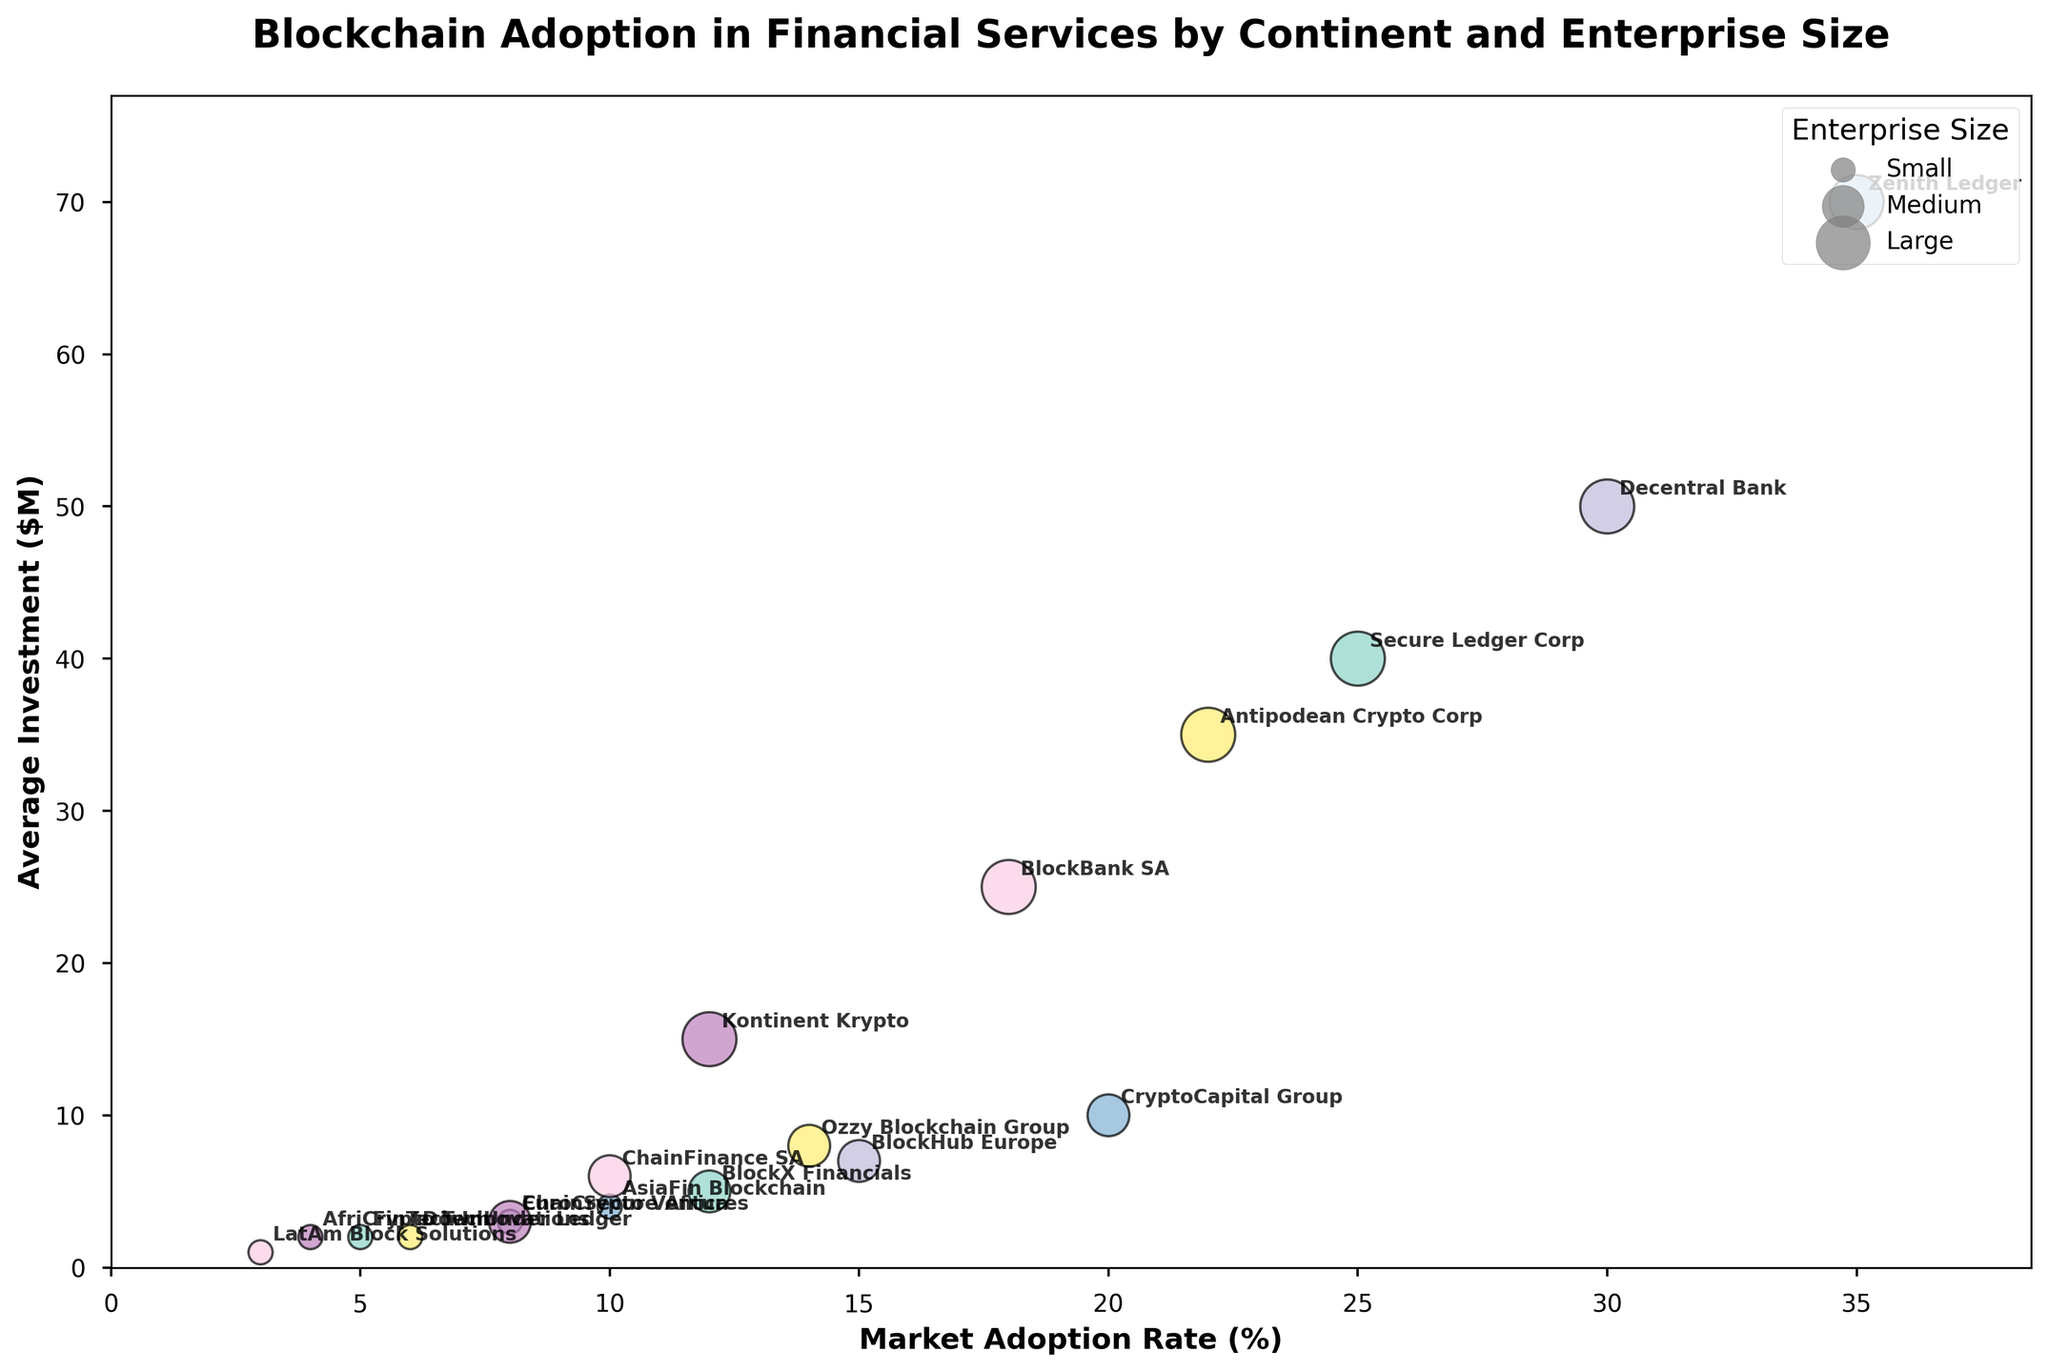What is the title of the figure? The title can be found at the top of the figure. The font is often larger and bolder, indicating it is a title.
Answer: Blockchain Adoption in Financial Services by Continent and Enterprise Size How are the Medium enterprises represented in the plot? In bubble charts, different sizes often represent a different group. Medium enterprises are typically denoted by medium-sized bubbles. You can also confirm this by looking at the legend marked 'Enterprise Size' on the plot, which has a size legend indicating the sizes for Small, Medium, and Large enterprises.
Answer: Medium-sized bubbles Which continent has the highest market adoption rate for large enterprises? By identifying the largest bubbles on the x-axis where 'Market Adoption Rate (%)' is highest, and then checking their colors against the legend, we see that Asia has the highest rate for large enterprises.
Answer: Asia What is the range of average investments for small enterprises across all continents? Locate the small-sized bubbles in the chart. The y-axis denotes 'Average Investment ($M)'. By checking these values, we see Small enterprises' investments range from around 1M (South America) to 4.0M (Asia).
Answer: 1M to 4M dollars What is the average market adoption rate of medium enterprises in Europe and North America combined? Locate the medium-sized bubbles for Europe and North America. Their 'Market Adoption Rate (%)' are 15% and 12% respectively. Averaging them: (15 + 12) / 2 = 13.5%
Answer: 13.5% Which entity in North America has the largest average investment? Locate the North America section in the figure and identify the size of the bubbles. The largest size bubble signifies the largest enterprise with the biggest investment. According to the data, Secure Ledger Corp has the largest average investment at $40M.
Answer: Secure Ledger Corp How does the market adoption rate of BlockHub Europe compare to ChainFinance SA? Identify 'BlockHub Europe' and 'ChainFinance SA' on the chart. BlockHub Europe's adoption rate is 15%, whereas ChainFinance SA's adoption rate is 10%.
Answer: BlockHub Europe has a higher rate Which small enterprise has the lowest market adoption rate? Find the smallest bubbles on the x-axis representing 'Market Adoption Rate (%)'. The South American entity 'LatAm Block Solutions' has the lowest adoption rate at 3%.
Answer: LatAm Block Solutions What color represents Australia on the plot, and which company has the highest investment there? Refer to the legend for Australia, which shows a specific color. Look for the largest bubble within that color, representing the largest enterprise. The highest investment entity in Australia is Antipodean Crypto Corp with $35M.
Answer: Antipodean Crypto Corp Is there a correlation between the average investment and market adoption rate for large enterprises in Asia? Examine the placement of the largest bubbles in Asia along the x-axis and y-axis. High market adoption rates and high average investments tend to align closely, suggesting a positive correlation.
Answer: Positive correlation 